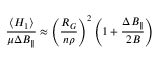Convert formula to latex. <formula><loc_0><loc_0><loc_500><loc_500>\frac { \left \langle H _ { 1 } \right \rangle } { \mu \Delta B _ { \| } } \approx \left ( \frac { R _ { G } } { n \rho } \right ) ^ { 2 } \left ( 1 + \frac { \Delta B _ { \| } } { 2 B } \right )</formula> 